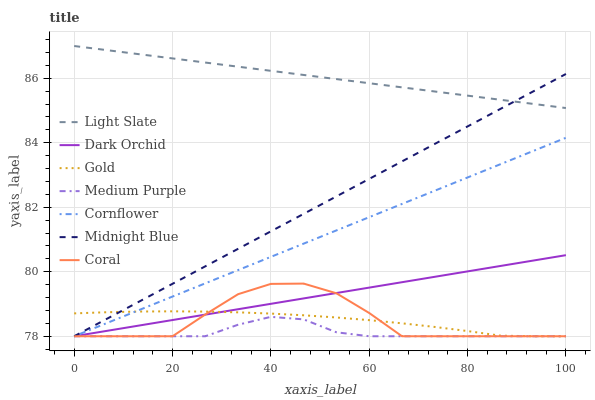Does Medium Purple have the minimum area under the curve?
Answer yes or no. Yes. Does Light Slate have the maximum area under the curve?
Answer yes or no. Yes. Does Midnight Blue have the minimum area under the curve?
Answer yes or no. No. Does Midnight Blue have the maximum area under the curve?
Answer yes or no. No. Is Light Slate the smoothest?
Answer yes or no. Yes. Is Coral the roughest?
Answer yes or no. Yes. Is Midnight Blue the smoothest?
Answer yes or no. No. Is Midnight Blue the roughest?
Answer yes or no. No. Does Cornflower have the lowest value?
Answer yes or no. Yes. Does Light Slate have the lowest value?
Answer yes or no. No. Does Light Slate have the highest value?
Answer yes or no. Yes. Does Midnight Blue have the highest value?
Answer yes or no. No. Is Cornflower less than Light Slate?
Answer yes or no. Yes. Is Light Slate greater than Cornflower?
Answer yes or no. Yes. Does Cornflower intersect Midnight Blue?
Answer yes or no. Yes. Is Cornflower less than Midnight Blue?
Answer yes or no. No. Is Cornflower greater than Midnight Blue?
Answer yes or no. No. Does Cornflower intersect Light Slate?
Answer yes or no. No. 